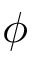<formula> <loc_0><loc_0><loc_500><loc_500>\phi</formula> 